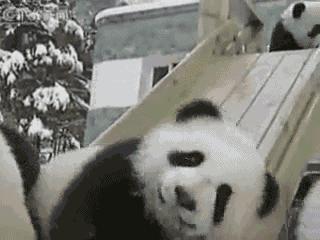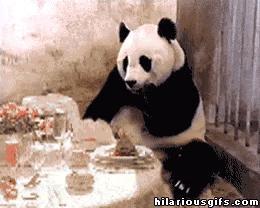The first image is the image on the left, the second image is the image on the right. Given the left and right images, does the statement "There are two pandas with some visible space between them." hold true? Answer yes or no. Yes. The first image is the image on the left, the second image is the image on the right. For the images displayed, is the sentence "An image shows at least two pandas falling backward down a slide with gray banisters." factually correct? Answer yes or no. No. 